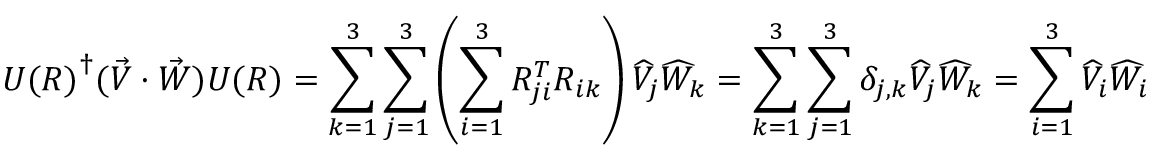<formula> <loc_0><loc_0><loc_500><loc_500>{ U ( R ) } ^ { \dagger } ( { \vec { V } } \cdot { \vec { W } } ) U ( R ) = \sum _ { k = 1 } ^ { 3 } \sum _ { j = 1 } ^ { 3 } \left ( \sum _ { i = 1 } ^ { 3 } R _ { j i } ^ { T } R _ { i k } \right ) { \widehat { V } } _ { j } { \widehat { W } } _ { k } = \sum _ { k = 1 } ^ { 3 } \sum _ { j = 1 } ^ { 3 } \delta _ { j , k } { \widehat { V } } _ { j } { \widehat { W } } _ { k } = \sum _ { i = 1 } ^ { 3 } { \widehat { V } } _ { i } { \widehat { W } } _ { i }</formula> 